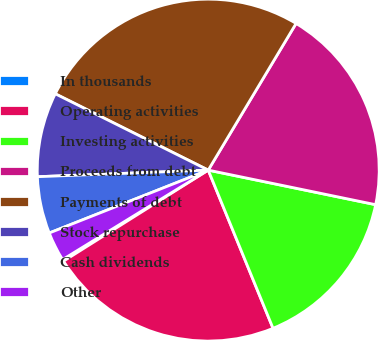Convert chart. <chart><loc_0><loc_0><loc_500><loc_500><pie_chart><fcel>In thousands<fcel>Operating activities<fcel>Investing activities<fcel>Proceeds from debt<fcel>Payments of debt<fcel>Stock repurchase<fcel>Cash dividends<fcel>Other<nl><fcel>0.17%<fcel>22.25%<fcel>15.57%<fcel>19.65%<fcel>26.22%<fcel>7.98%<fcel>5.38%<fcel>2.77%<nl></chart> 